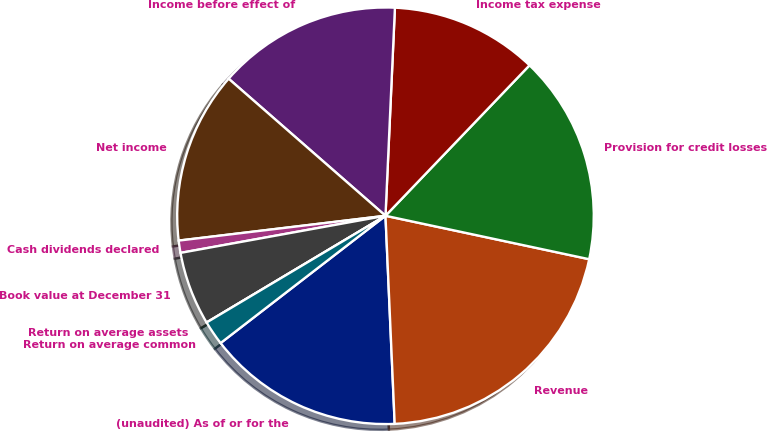<chart> <loc_0><loc_0><loc_500><loc_500><pie_chart><fcel>(unaudited) As of or for the<fcel>Revenue<fcel>Provision for credit losses<fcel>Income tax expense<fcel>Income before effect of<fcel>Net income<fcel>Cash dividends declared<fcel>Book value at December 31<fcel>Return on average assets<fcel>Return on average common<nl><fcel>15.24%<fcel>20.95%<fcel>16.19%<fcel>11.43%<fcel>14.29%<fcel>13.33%<fcel>0.95%<fcel>5.71%<fcel>0.0%<fcel>1.9%<nl></chart> 